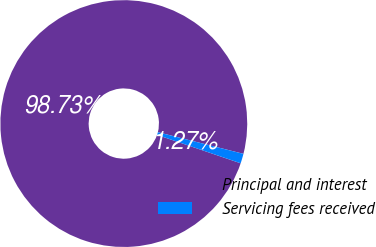Convert chart to OTSL. <chart><loc_0><loc_0><loc_500><loc_500><pie_chart><fcel>Principal and interest<fcel>Servicing fees received<nl><fcel>98.73%<fcel>1.27%<nl></chart> 